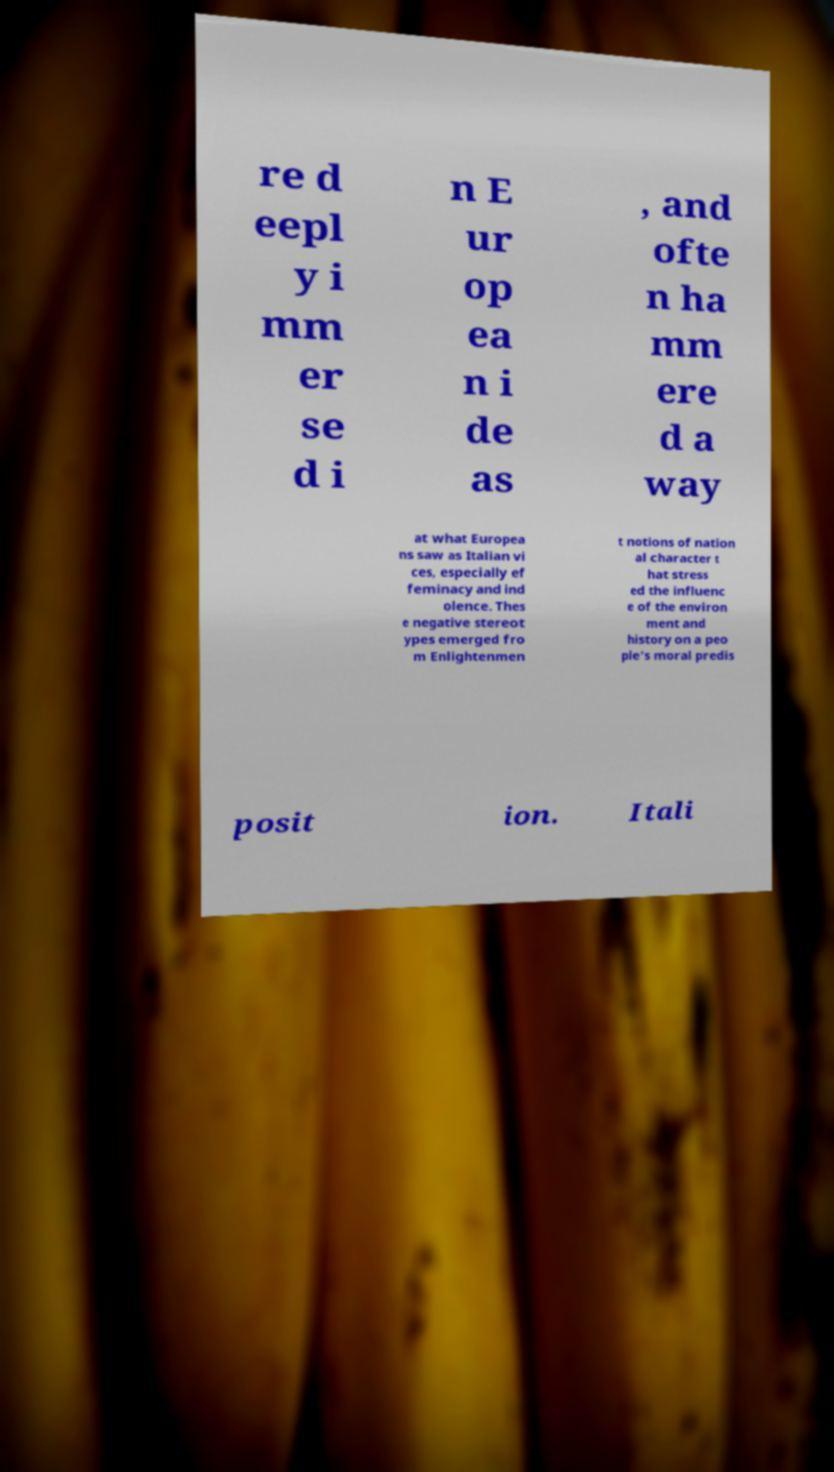Please read and relay the text visible in this image. What does it say? re d eepl y i mm er se d i n E ur op ea n i de as , and ofte n ha mm ere d a way at what Europea ns saw as Italian vi ces, especially ef feminacy and ind olence. Thes e negative stereot ypes emerged fro m Enlightenmen t notions of nation al character t hat stress ed the influenc e of the environ ment and history on a peo ple's moral predis posit ion. Itali 